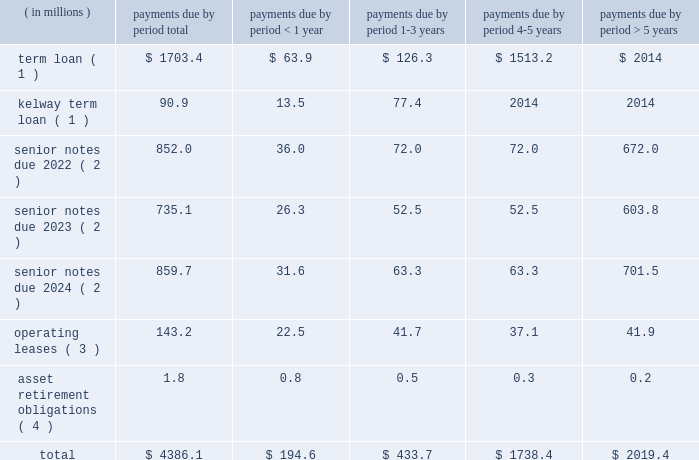Table of contents ended december 31 , 2015 and 2014 , respectively .
The increase in cash provided by accounts payable-inventory financing was primarily due to a new vendor added to our previously existing inventory financing agreement .
For a description of the inventory financing transactions impacting each period , see note 6 ( inventory financing agreements ) to the accompanying consolidated financial statements .
For a description of the debt transactions impacting each period , see note 8 ( long-term debt ) to the accompanying consolidated financial statements .
Net cash used in financing activities decreased $ 56.3 million in 2014 compared to 2013 .
The decrease was primarily driven by several debt refinancing transactions during each period and our july 2013 ipo , which generated net proceeds of $ 424.7 million after deducting underwriting discounts , expenses and transaction costs .
The net impact of our debt transactions resulted in cash outflows of $ 145.9 million and $ 518.3 million during 2014 and 2013 , respectively , as cash was used in each period to reduce our total long-term debt .
For a description of the debt transactions impacting each period , see note 8 ( long-term debt ) to the accompanying consolidated financial statements .
Long-term debt and financing arrangements as of december 31 , 2015 , we had total indebtedness of $ 3.3 billion , of which $ 1.6 billion was secured indebtedness .
At december 31 , 2015 , we were in compliance with the covenants under our various credit agreements and indentures .
The amount of cdw 2019s restricted payment capacity under the senior secured term loan facility was $ 679.7 million at december 31 , 2015 .
For further details regarding our debt and each of the transactions described below , see note 8 ( long-term debt ) to the accompanying consolidated financial statements .
During the year ended december 31 , 2015 , the following events occurred with respect to our debt structure : 2022 on august 1 , 2015 , we consolidated kelway 2019s term loan and kelway 2019s revolving credit facility .
Kelway 2019s term loan is denominated in british pounds .
The kelway revolving credit facility is a multi-currency revolving credit facility under which kelway is permitted to borrow an aggregate amount of a350.0 million ( $ 73.7 million ) as of december 31 , 2015 .
2022 on march 3 , 2015 , we completed the issuance of $ 525.0 million principal amount of 5.0% ( 5.0 % ) senior notes due 2023 which will mature on september 1 , 2023 .
2022 on march 3 , 2015 , we redeemed the remaining $ 503.9 million aggregate principal amount of the 8.5% ( 8.5 % ) senior notes due 2019 , plus accrued and unpaid interest through the date of redemption , april 2 , 2015 .
Inventory financing agreements we have entered into agreements with certain financial intermediaries to facilitate the purchase of inventory from various suppliers under certain terms and conditions .
These amounts are classified separately as accounts payable-inventory financing on the consolidated balance sheets .
We do not incur any interest expense associated with these agreements as balances are paid when they are due .
For further details , see note 6 ( inventory financing agreements ) to the accompanying consolidated financial statements .
Contractual obligations we have future obligations under various contracts relating to debt and interest payments , operating leases and asset retirement obligations .
Our estimated future payments , based on undiscounted amounts , under contractual obligations that existed as of december 31 , 2015 , are as follows: .

What was the percent of the total term loan that was due in 1-3 years? 
Computations: (126.3 / 1703.4)
Answer: 0.07415. 